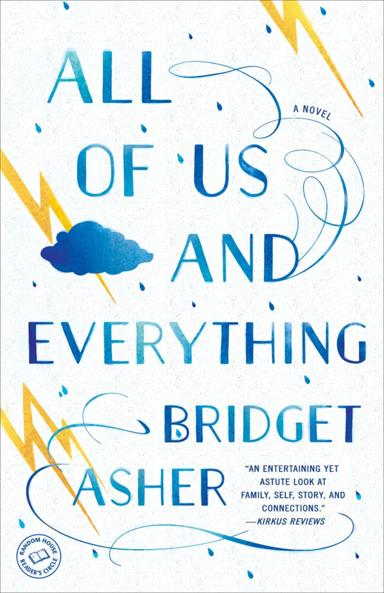What is the title of the novel mentioned in the image? The novel depicted in the image is titled "All of Us and Everything" by Bridget Asher. This captivating book explores the intricacies of family dynamics and personal discovery. 